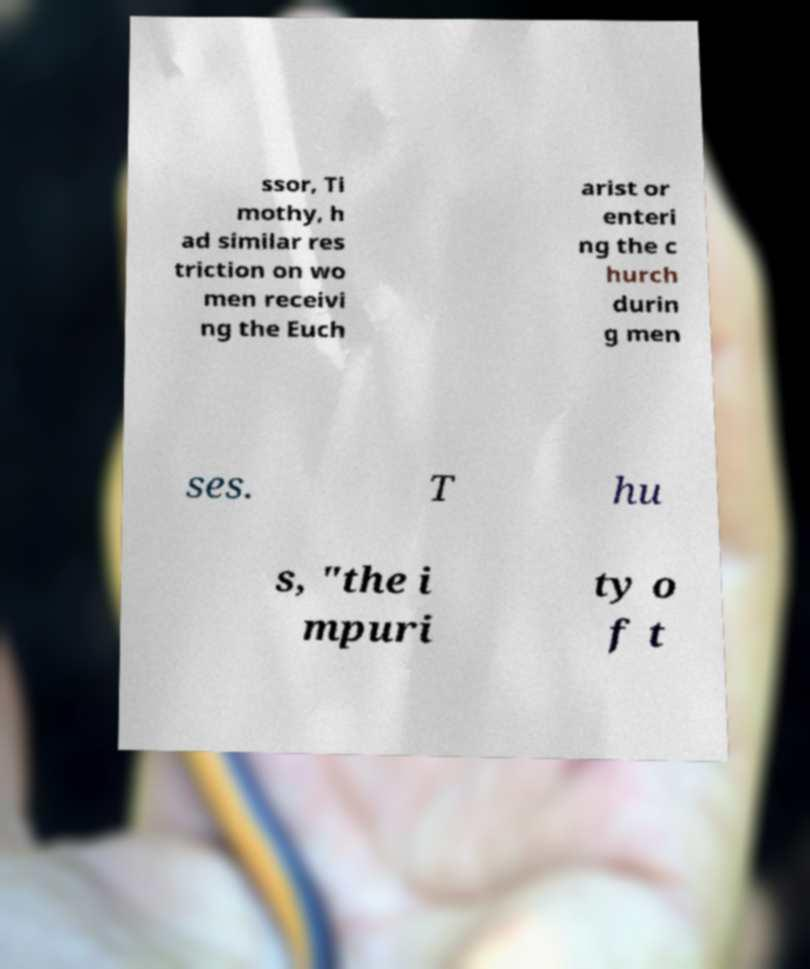Can you accurately transcribe the text from the provided image for me? ssor, Ti mothy, h ad similar res triction on wo men receivi ng the Euch arist or enteri ng the c hurch durin g men ses. T hu s, "the i mpuri ty o f t 